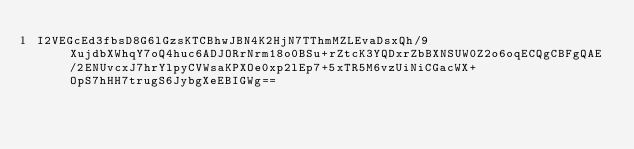<code> <loc_0><loc_0><loc_500><loc_500><_SML_>I2VEGcEd3fbsD8G6lGzsKTCBhwJBN4K2HjN7TThmMZLEvaDsxQh/9XujdbXWhqY7oQ4huc6ADJORrNrm18o0BSu+rZtcK3YQDxrZbBXNSUW0Z2o6oqECQgCBFgQAE/2ENUvcxJ7hrYlpyCVWsaKPXOe0xp2lEp7+5xTR5M6vzUiNiCGacWX+OpS7hHH7trugS6JybgXeEBIGWg==</code> 